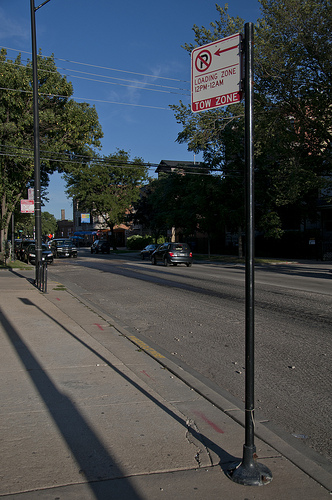What is the color of the car on the road?
Answer the question using a single word or phrase. Dark blue 